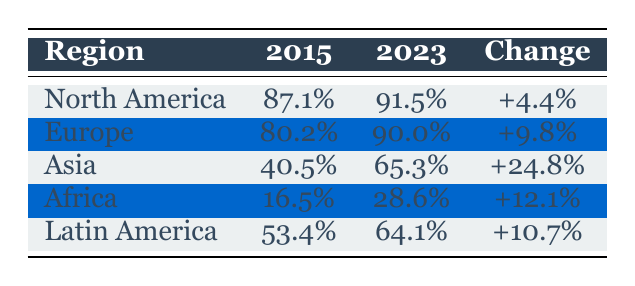What was the internet penetration rate in North America in 2015? The table shows that the penetration rate in North America for the year 2015 is 87.1%.
Answer: 87.1% Which region saw the highest increase in internet penetration rate from 2015 to 2023? By comparing the changes in penetration rates, Asia shows an increase of 24.8%, which is the highest among all regions.
Answer: Asia What is the average internet penetration rate across all regions in 2023? The rates for each region in 2023 are: North America (91.5%), Europe (90.0%), Asia (65.3%), Africa (28.6%), and Latin America (64.1%). The total is 90.0 + 91.5 + 65.3 + 28.6 + 64.1 = 339.5. Dividing by 5 gives an average of 67.9%.
Answer: 67.9% Did Africa have a higher percentage increase in internet penetration compared to Latin America? Africa's increase is 12.1% and Latin America's is 10.7%. Since 12.1% is greater than 10.7%, the statement is true.
Answer: Yes What is the difference in internet penetration rate between Europe and Africa in 2023? In 2023, Europe has a penetration rate of 90.0% and Africa has 28.6%. The difference is 90.0 - 28.6 = 61.4%.
Answer: 61.4% 